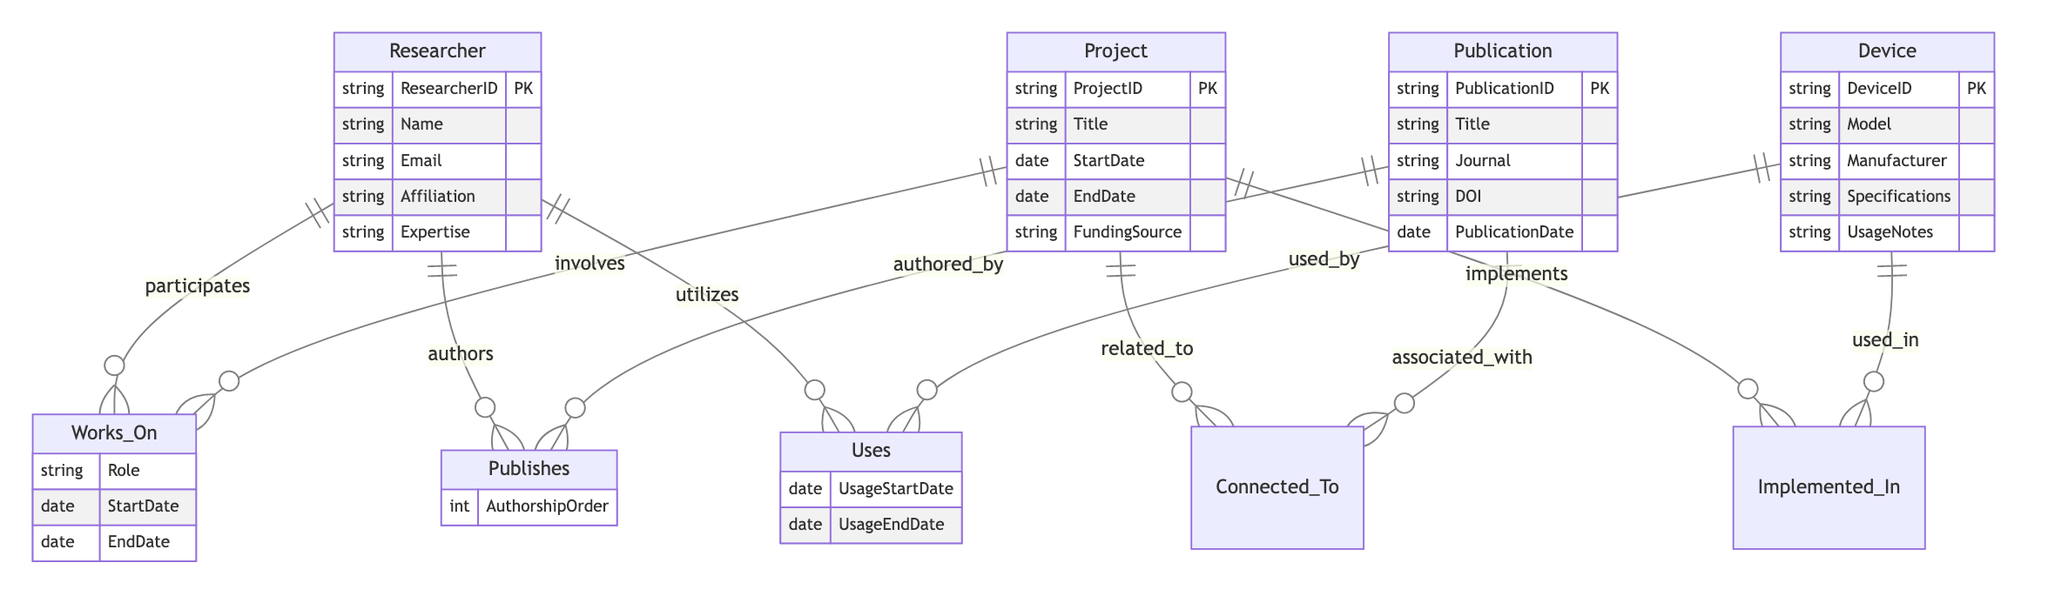What is the primary key for the Researcher entity? The primary key for the Researcher entity is ResearcherID, which uniquely identifies each researcher in the database.
Answer: ResearcherID How many attributes does the Project entity have? The Project entity has 5 attributes: ProjectID, Title, StartDate, EndDate, and FundingSource.
Answer: 5 What relationship connects a Project to a Publication? The relationship that connects a Project to a Publication is called Connected_To, indicating that there is a relevant association between the two.
Answer: Connected_To What is an attribute of the Uses relationship? An attribute of the Uses relationship is UsageStartDate, which records the start date of using a device.
Answer: UsageStartDate Which entity has the attribute DOI? The attribute DOI belongs to the Publication entity, as it is used to uniquely identify published works.
Answer: Publication How many relationships are associated with the Researcher entity? The Researcher entity is associated with 3 relationships: Works_On, Publishes, and Uses, indicating various interactions in the research context.
Answer: 3 What is the role of a Researcher in a Project? The role of a Researcher in a Project can be described by the attribute Role within the Works_On relationship, which specifies the function of the researcher in that particular project.
Answer: Role Which entity is implemented in a Project using a Device? The relationship Implemented_In indicates which Device is utilized within a Project, reflecting the integration of devices in stress monitoring studies.
Answer: Device What does the attribute AuthorshipOrder signify? The AuthorshipOrder attribute signifies the order of contribution of a Researcher in a Publication, indicating their level of involvement.
Answer: AuthorshipOrder 